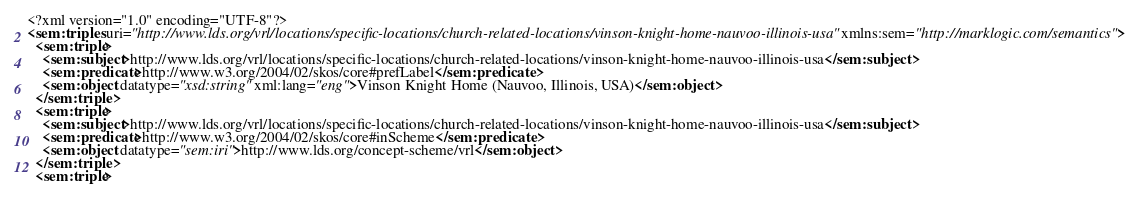<code> <loc_0><loc_0><loc_500><loc_500><_XML_><?xml version="1.0" encoding="UTF-8"?>
<sem:triples uri="http://www.lds.org/vrl/locations/specific-locations/church-related-locations/vinson-knight-home-nauvoo-illinois-usa" xmlns:sem="http://marklogic.com/semantics">
  <sem:triple>
    <sem:subject>http://www.lds.org/vrl/locations/specific-locations/church-related-locations/vinson-knight-home-nauvoo-illinois-usa</sem:subject>
    <sem:predicate>http://www.w3.org/2004/02/skos/core#prefLabel</sem:predicate>
    <sem:object datatype="xsd:string" xml:lang="eng">Vinson Knight Home (Nauvoo, Illinois, USA)</sem:object>
  </sem:triple>
  <sem:triple>
    <sem:subject>http://www.lds.org/vrl/locations/specific-locations/church-related-locations/vinson-knight-home-nauvoo-illinois-usa</sem:subject>
    <sem:predicate>http://www.w3.org/2004/02/skos/core#inScheme</sem:predicate>
    <sem:object datatype="sem:iri">http://www.lds.org/concept-scheme/vrl</sem:object>
  </sem:triple>
  <sem:triple></code> 